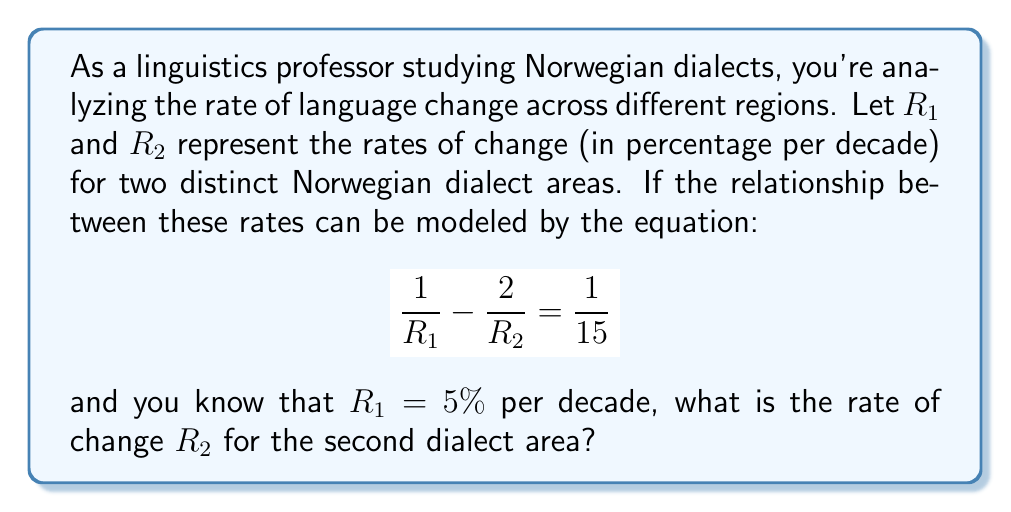What is the answer to this math problem? Let's solve this step-by-step:

1) We start with the given equation:
   $$\frac{1}{R_1} - \frac{2}{R_2} = \frac{1}{15}$$

2) We know that $R_1 = 5\%$ per decade, or $R_1 = 5$ when expressed as a percentage. Let's substitute this:
   $$\frac{1}{5} - \frac{2}{R_2} = \frac{1}{15}$$

3) Now, let's solve for $\frac{2}{R_2}$:
   $$\frac{2}{R_2} = \frac{1}{5} - \frac{1}{15}$$

4) Find a common denominator to subtract the fractions:
   $$\frac{2}{R_2} = \frac{3}{15} - \frac{1}{15} = \frac{2}{15}$$

5) Now we have:
   $$\frac{2}{R_2} = \frac{2}{15}$$

6) Multiply both sides by $R_2$:
   $$2 = \frac{2R_2}{15}$$

7) Multiply both sides by 15:
   $$30 = 2R_2$$

8) Divide both sides by 2:
   $$15 = R_2$$

Therefore, the rate of change for the second dialect area, $R_2$, is 15% per decade.
Answer: 15% per decade 